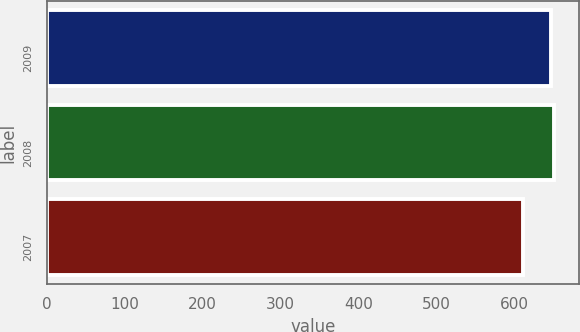Convert chart. <chart><loc_0><loc_0><loc_500><loc_500><bar_chart><fcel>2009<fcel>2008<fcel>2007<nl><fcel>647<fcel>650.6<fcel>612<nl></chart> 